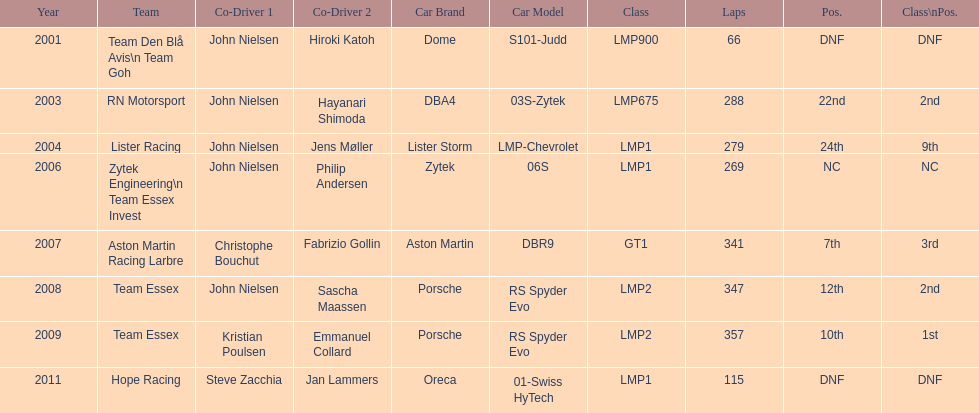In 2008 and what other year was casper elgaard on team essex for the 24 hours of le mans? 2009. Parse the full table. {'header': ['Year', 'Team', 'Co-Driver 1', 'Co-Driver 2', 'Car Brand', 'Car Model', 'Class', 'Laps', 'Pos.', 'Class\\nPos.'], 'rows': [['2001', 'Team Den Blå Avis\\n Team Goh', 'John Nielsen', 'Hiroki Katoh', 'Dome', 'S101-Judd', 'LMP900', '66', 'DNF', 'DNF'], ['2003', 'RN Motorsport', 'John Nielsen', 'Hayanari Shimoda', 'DBA4', '03S-Zytek', 'LMP675', '288', '22nd', '2nd'], ['2004', 'Lister Racing', 'John Nielsen', 'Jens Møller', 'Lister Storm', 'LMP-Chevrolet', 'LMP1', '279', '24th', '9th'], ['2006', 'Zytek Engineering\\n Team Essex Invest', 'John Nielsen', 'Philip Andersen', 'Zytek', '06S', 'LMP1', '269', 'NC', 'NC'], ['2007', 'Aston Martin Racing Larbre', 'Christophe Bouchut', 'Fabrizio Gollin', 'Aston Martin', 'DBR9', 'GT1', '341', '7th', '3rd'], ['2008', 'Team Essex', 'John Nielsen', 'Sascha Maassen', 'Porsche', 'RS Spyder Evo', 'LMP2', '347', '12th', '2nd'], ['2009', 'Team Essex', 'Kristian Poulsen', 'Emmanuel Collard', 'Porsche', 'RS Spyder Evo', 'LMP2', '357', '10th', '1st'], ['2011', 'Hope Racing', 'Steve Zacchia', 'Jan Lammers', 'Oreca', '01-Swiss HyTech', 'LMP1', '115', 'DNF', 'DNF']]} 